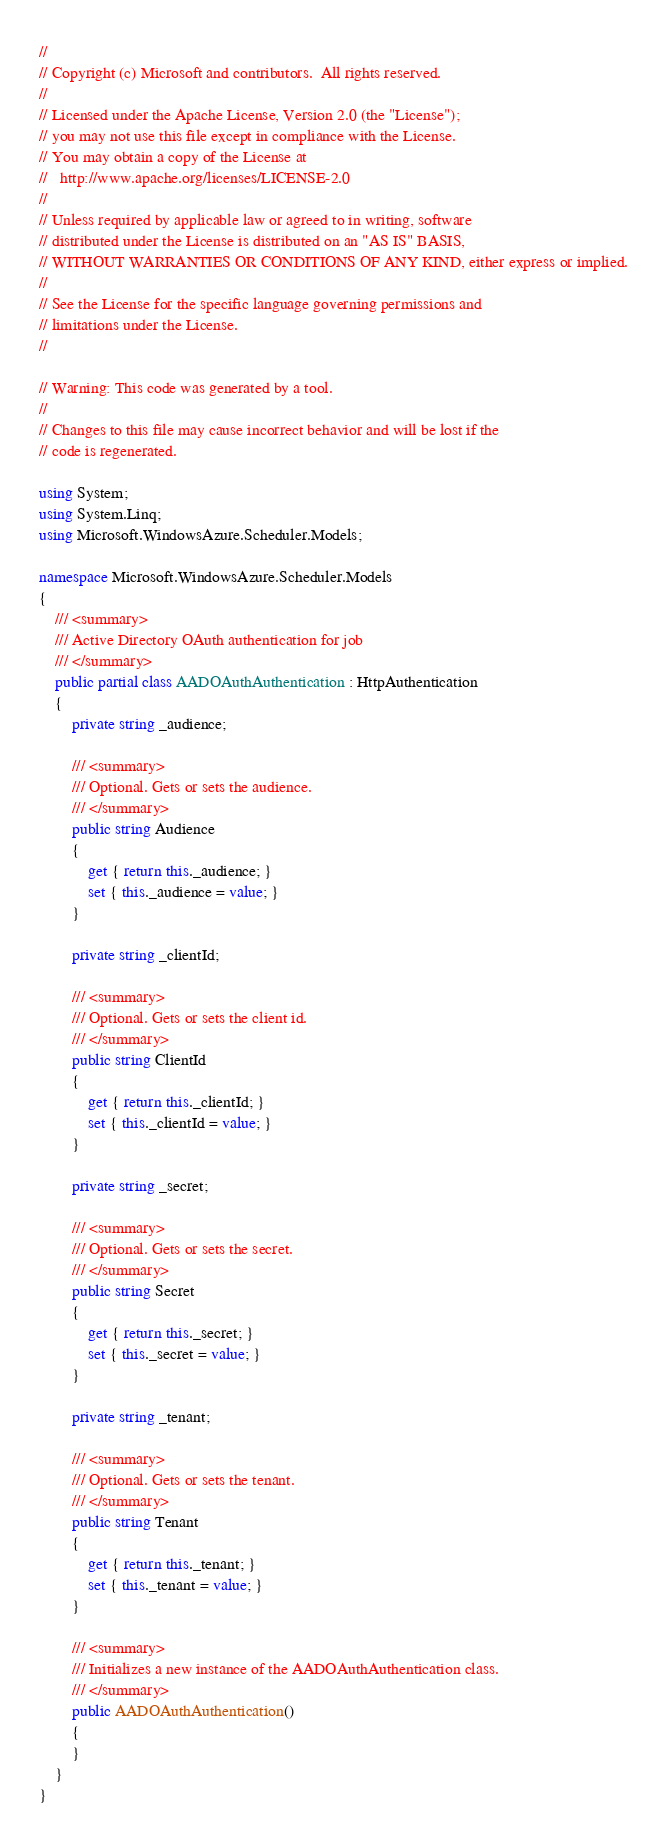Convert code to text. <code><loc_0><loc_0><loc_500><loc_500><_C#_>// 
// Copyright (c) Microsoft and contributors.  All rights reserved.
// 
// Licensed under the Apache License, Version 2.0 (the "License");
// you may not use this file except in compliance with the License.
// You may obtain a copy of the License at
//   http://www.apache.org/licenses/LICENSE-2.0
// 
// Unless required by applicable law or agreed to in writing, software
// distributed under the License is distributed on an "AS IS" BASIS,
// WITHOUT WARRANTIES OR CONDITIONS OF ANY KIND, either express or implied.
// 
// See the License for the specific language governing permissions and
// limitations under the License.
// 

// Warning: This code was generated by a tool.
// 
// Changes to this file may cause incorrect behavior and will be lost if the
// code is regenerated.

using System;
using System.Linq;
using Microsoft.WindowsAzure.Scheduler.Models;

namespace Microsoft.WindowsAzure.Scheduler.Models
{
    /// <summary>
    /// Active Directory OAuth authentication for job
    /// </summary>
    public partial class AADOAuthAuthentication : HttpAuthentication
    {
        private string _audience;
        
        /// <summary>
        /// Optional. Gets or sets the audience.
        /// </summary>
        public string Audience
        {
            get { return this._audience; }
            set { this._audience = value; }
        }
        
        private string _clientId;
        
        /// <summary>
        /// Optional. Gets or sets the client id.
        /// </summary>
        public string ClientId
        {
            get { return this._clientId; }
            set { this._clientId = value; }
        }
        
        private string _secret;
        
        /// <summary>
        /// Optional. Gets or sets the secret.
        /// </summary>
        public string Secret
        {
            get { return this._secret; }
            set { this._secret = value; }
        }
        
        private string _tenant;
        
        /// <summary>
        /// Optional. Gets or sets the tenant.
        /// </summary>
        public string Tenant
        {
            get { return this._tenant; }
            set { this._tenant = value; }
        }
        
        /// <summary>
        /// Initializes a new instance of the AADOAuthAuthentication class.
        /// </summary>
        public AADOAuthAuthentication()
        {
        }
    }
}
</code> 